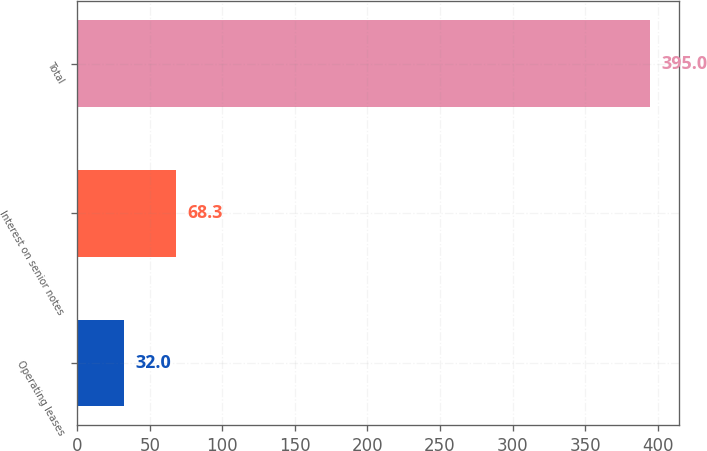Convert chart to OTSL. <chart><loc_0><loc_0><loc_500><loc_500><bar_chart><fcel>Operating leases<fcel>Interest on senior notes<fcel>Total<nl><fcel>32<fcel>68.3<fcel>395<nl></chart> 